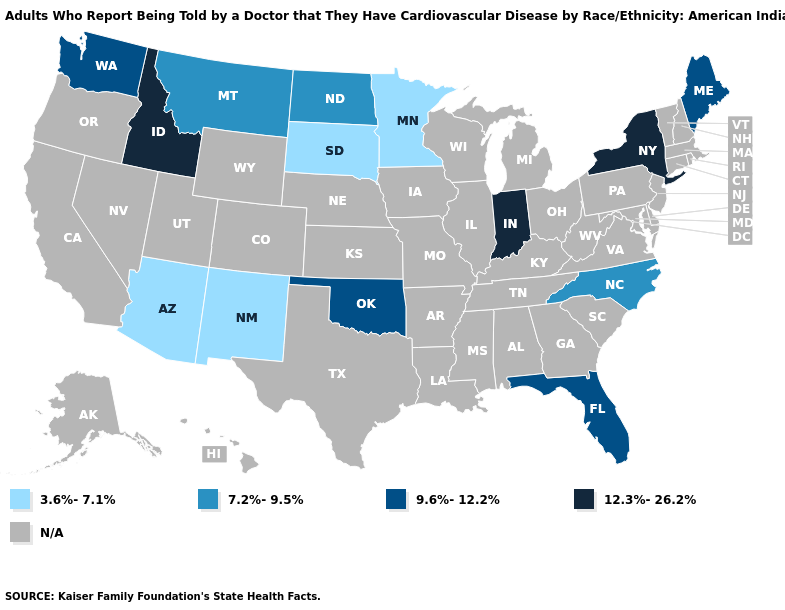Name the states that have a value in the range 9.6%-12.2%?
Be succinct. Florida, Maine, Oklahoma, Washington. Does Washington have the lowest value in the USA?
Give a very brief answer. No. What is the lowest value in the South?
Write a very short answer. 7.2%-9.5%. Name the states that have a value in the range 3.6%-7.1%?
Give a very brief answer. Arizona, Minnesota, New Mexico, South Dakota. What is the value of Michigan?
Write a very short answer. N/A. Which states hav the highest value in the MidWest?
Give a very brief answer. Indiana. Name the states that have a value in the range 9.6%-12.2%?
Give a very brief answer. Florida, Maine, Oklahoma, Washington. Which states hav the highest value in the Northeast?
Answer briefly. New York. Does Washington have the lowest value in the West?
Be succinct. No. What is the highest value in the South ?
Short answer required. 9.6%-12.2%. What is the highest value in the USA?
Concise answer only. 12.3%-26.2%. Name the states that have a value in the range 3.6%-7.1%?
Write a very short answer. Arizona, Minnesota, New Mexico, South Dakota. Among the states that border Vermont , which have the lowest value?
Concise answer only. New York. Does New Mexico have the lowest value in the USA?
Give a very brief answer. Yes. What is the lowest value in the USA?
Be succinct. 3.6%-7.1%. 